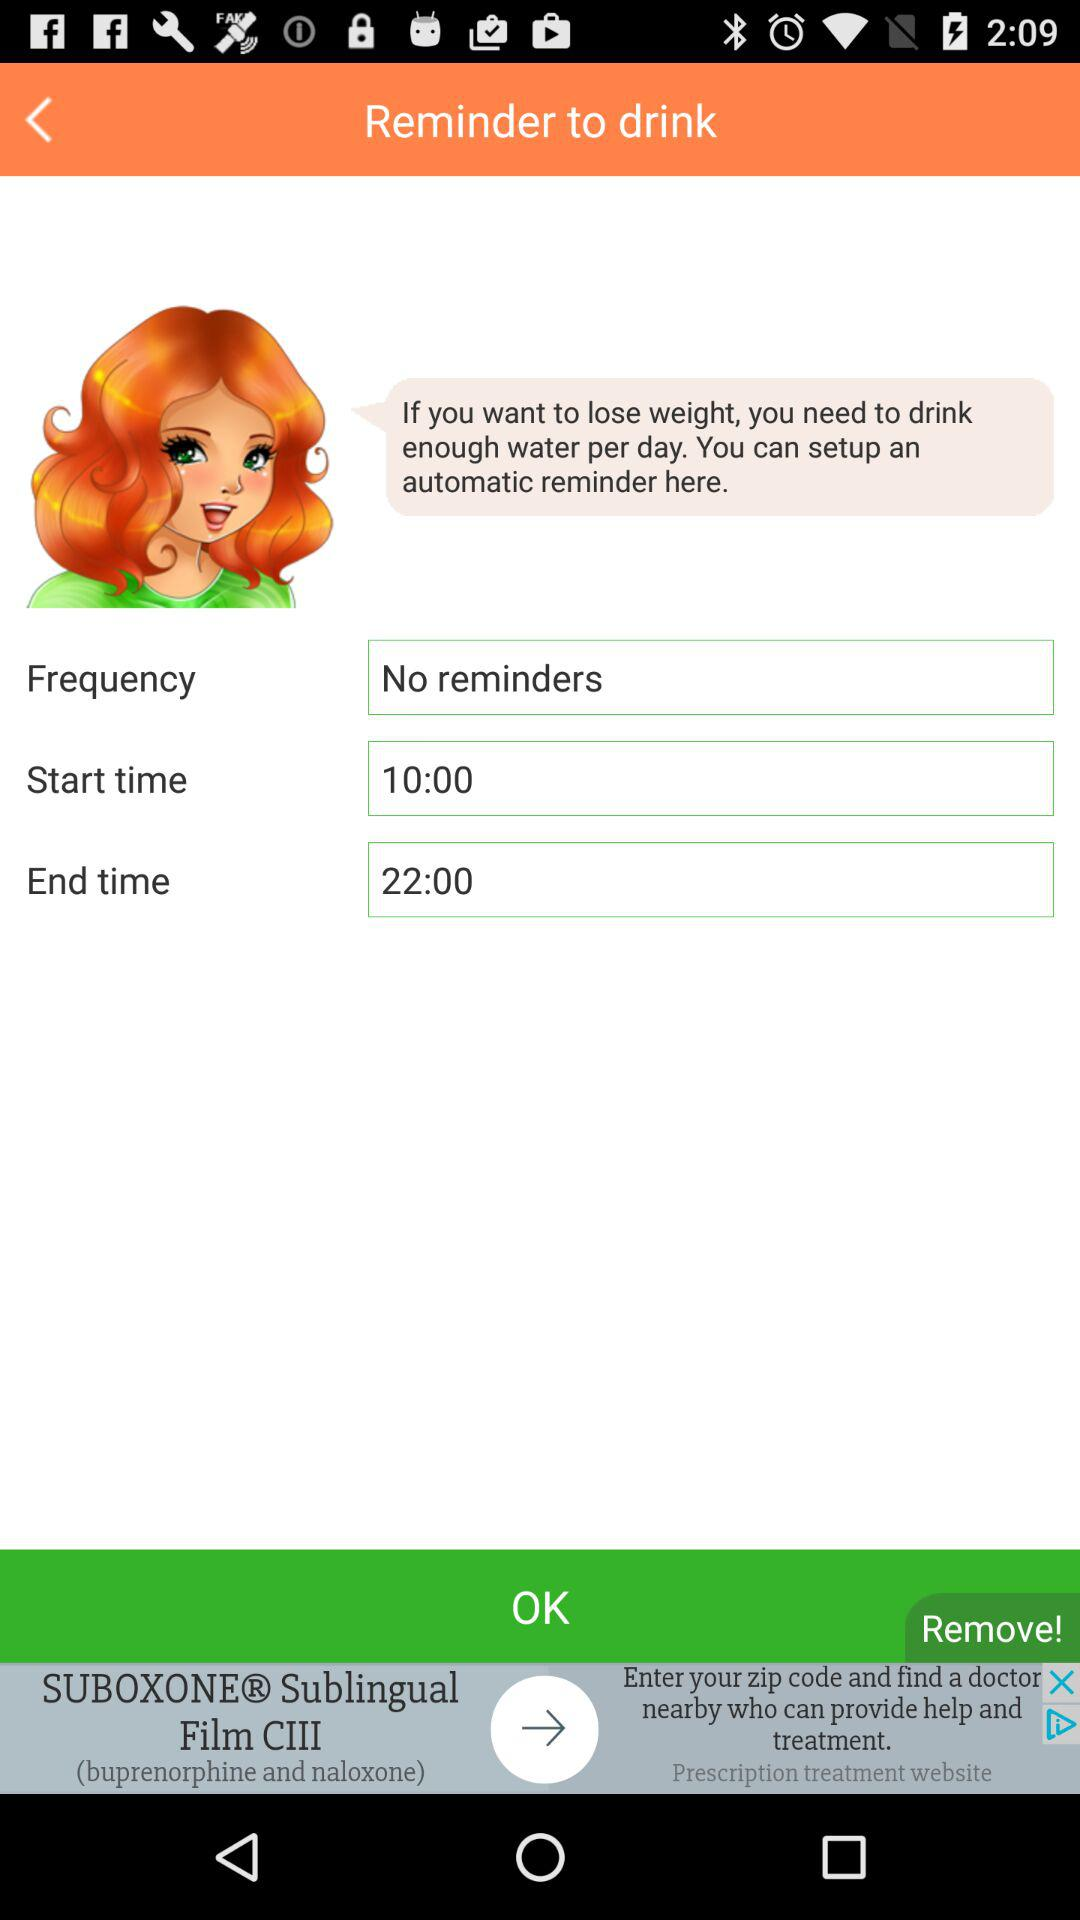What is the start time? The start time is 10:00. 